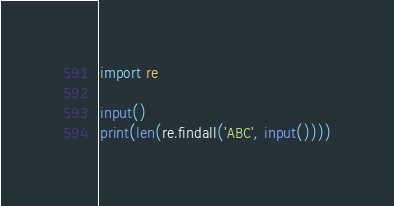Convert code to text. <code><loc_0><loc_0><loc_500><loc_500><_Python_>import re

input()
print(len(re.findall('ABC', input())))
</code> 